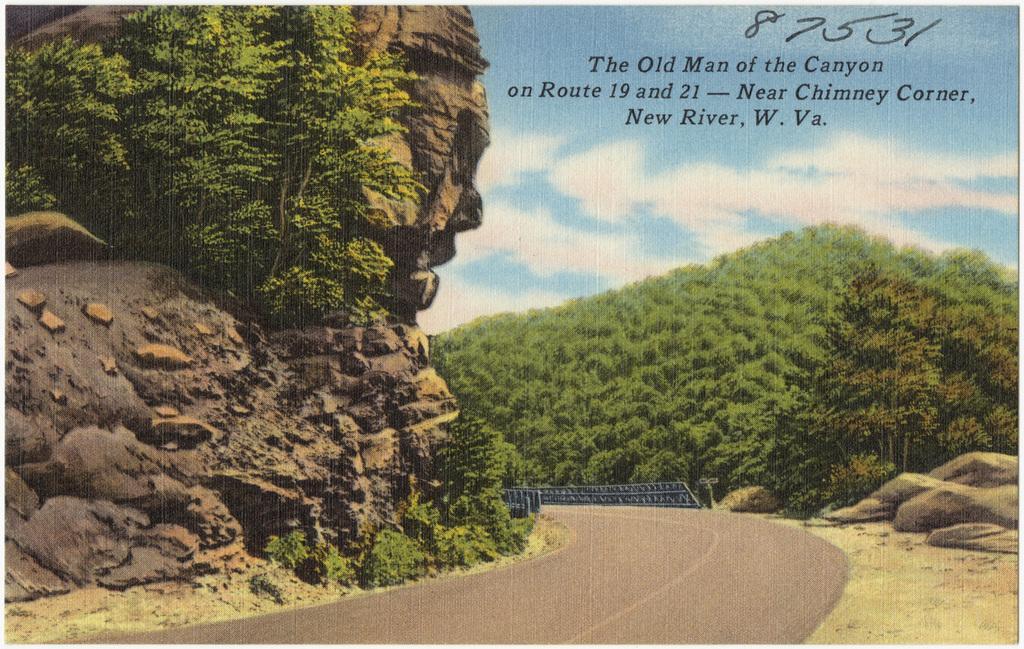Please provide a concise description of this image. In this image, we can see a poster. Here we can see there are so many trees, rocks, stones, road, railing. Top of the image, there is a cloudy sky. 